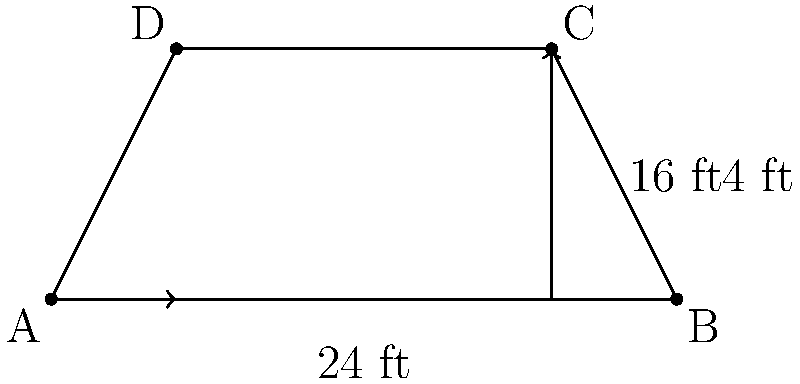At the Carmel Visitor Center, you're planning to install a new trapezoid-shaped viewing platform overlooking the ocean. The parallel sides of the platform measure 24 feet and 16 feet, with a height of 4 feet between them. What is the total area of this viewing platform in square feet? To find the area of a trapezoid, we can use the formula:

$$A = \frac{1}{2}(b_1 + b_2)h$$

Where:
$A$ = Area
$b_1$ = Length of one parallel side
$b_2$ = Length of the other parallel side
$h$ = Height (perpendicular distance between the parallel sides)

Given:
$b_1 = 24$ feet
$b_2 = 16$ feet
$h = 4$ feet

Let's substitute these values into the formula:

$$A = \frac{1}{2}(24 + 16) \times 4$$

Simplify:
$$A = \frac{1}{2}(40) \times 4$$
$$A = 20 \times 4$$
$$A = 80$$

Therefore, the area of the trapezoid-shaped viewing platform is 80 square feet.
Answer: 80 sq ft 